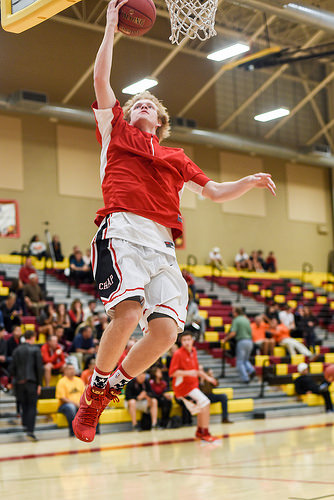<image>
Is there a stairs next to the basketball court? Yes. The stairs is positioned adjacent to the basketball court, located nearby in the same general area. 